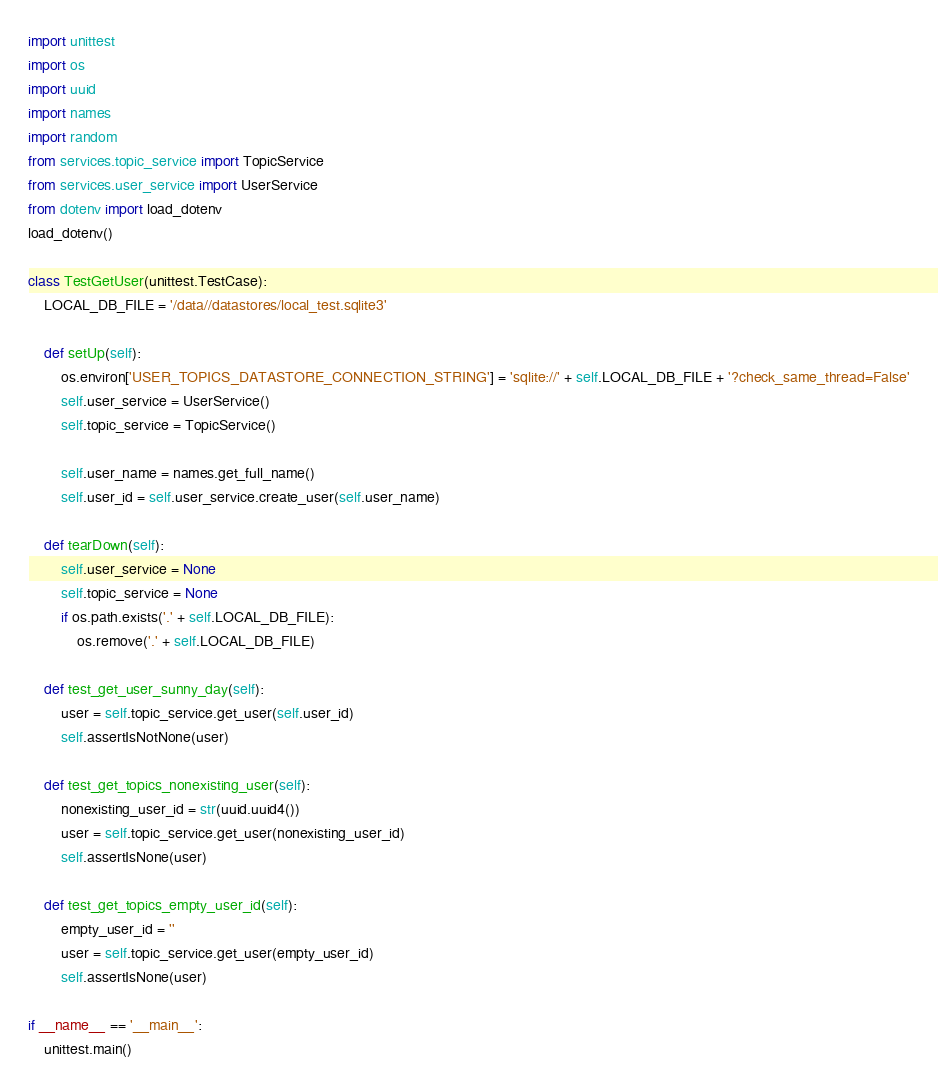<code> <loc_0><loc_0><loc_500><loc_500><_Python_>import unittest
import os
import uuid
import names
import random
from services.topic_service import TopicService
from services.user_service import UserService
from dotenv import load_dotenv
load_dotenv()

class TestGetUser(unittest.TestCase):
    LOCAL_DB_FILE = '/data//datastores/local_test.sqlite3'

    def setUp(self):
        os.environ['USER_TOPICS_DATASTORE_CONNECTION_STRING'] = 'sqlite://' + self.LOCAL_DB_FILE + '?check_same_thread=False'
        self.user_service = UserService()
        self.topic_service = TopicService()

        self.user_name = names.get_full_name()
        self.user_id = self.user_service.create_user(self.user_name)

    def tearDown(self):
        self.user_service = None
        self.topic_service = None
        if os.path.exists('.' + self.LOCAL_DB_FILE):
            os.remove('.' + self.LOCAL_DB_FILE)

    def test_get_user_sunny_day(self):
        user = self.topic_service.get_user(self.user_id)
        self.assertIsNotNone(user)

    def test_get_topics_nonexisting_user(self):
        nonexisting_user_id = str(uuid.uuid4())
        user = self.topic_service.get_user(nonexisting_user_id)
        self.assertIsNone(user)

    def test_get_topics_empty_user_id(self):
        empty_user_id = ''
        user = self.topic_service.get_user(empty_user_id)
        self.assertIsNone(user)
        
if __name__ == '__main__':
    unittest.main()

</code> 